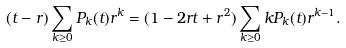<formula> <loc_0><loc_0><loc_500><loc_500>( t - r ) \sum _ { k \geq 0 } P _ { k } ( t ) r ^ { k } = ( 1 - 2 r t + r ^ { 2 } ) \sum _ { k \geq 0 } k P _ { k } ( t ) r ^ { k - 1 } .</formula> 